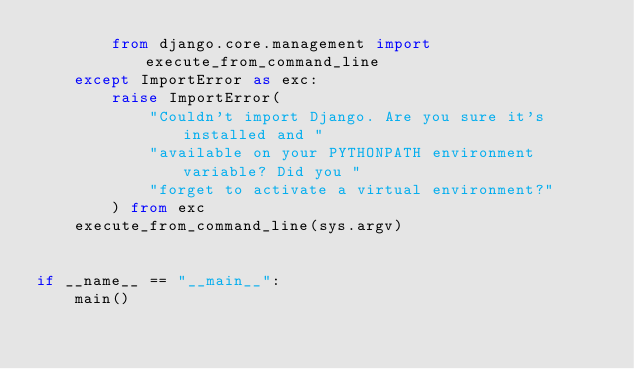Convert code to text. <code><loc_0><loc_0><loc_500><loc_500><_Python_>        from django.core.management import execute_from_command_line
    except ImportError as exc:
        raise ImportError(
            "Couldn't import Django. Are you sure it's installed and "
            "available on your PYTHONPATH environment variable? Did you "
            "forget to activate a virtual environment?"
        ) from exc
    execute_from_command_line(sys.argv)


if __name__ == "__main__":
    main()
</code> 